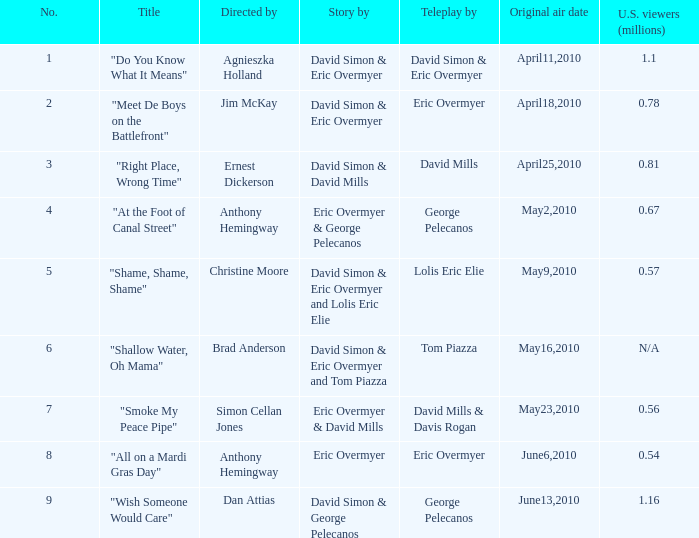Name the us viewers directed by christine moore 0.57. 